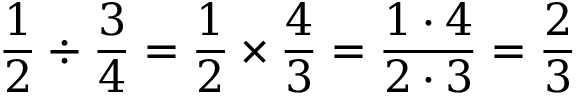<formula> <loc_0><loc_0><loc_500><loc_500>{ \frac { 1 } { 2 } } \div { \frac { 3 } { 4 } } = { \frac { 1 } { 2 } } \times { \frac { 4 } { 3 } } = { \frac { 1 \cdot 4 } { 2 \cdot 3 } } = { \frac { 2 } { 3 } }</formula> 